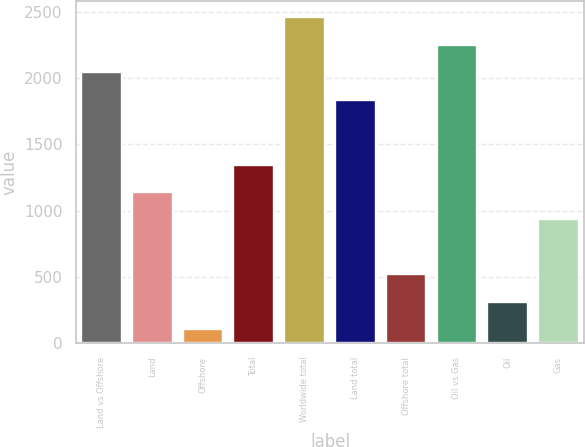Convert chart. <chart><loc_0><loc_0><loc_500><loc_500><bar_chart><fcel>Land vs Offshore<fcel>Land<fcel>Offshore<fcel>Total<fcel>Worldwide total<fcel>Land total<fcel>Offshore total<fcel>Oil vs Gas<fcel>Oil<fcel>Gas<nl><fcel>2042.6<fcel>1141<fcel>108<fcel>1347.6<fcel>2455.8<fcel>1836<fcel>521.2<fcel>2249.2<fcel>314.6<fcel>934.4<nl></chart> 